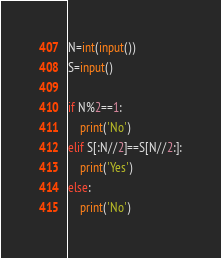<code> <loc_0><loc_0><loc_500><loc_500><_Python_>N=int(input())
S=input()

if N%2==1:
    print('No')
elif S[:N//2]==S[N//2:]:
    print('Yes')
else:
    print('No')</code> 